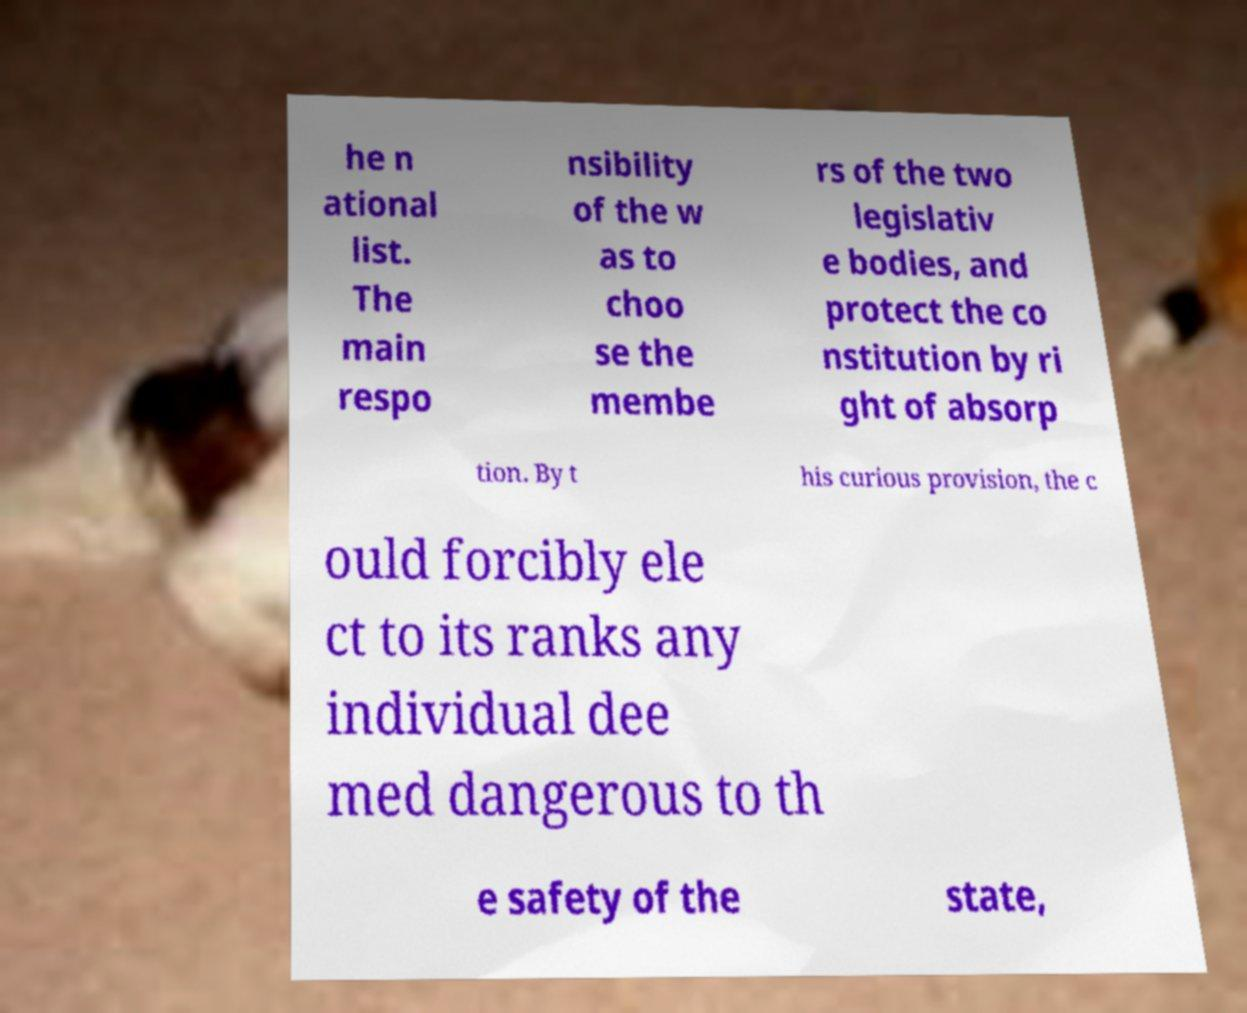Please identify and transcribe the text found in this image. he n ational list. The main respo nsibility of the w as to choo se the membe rs of the two legislativ e bodies, and protect the co nstitution by ri ght of absorp tion. By t his curious provision, the c ould forcibly ele ct to its ranks any individual dee med dangerous to th e safety of the state, 